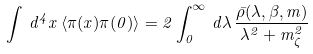<formula> <loc_0><loc_0><loc_500><loc_500>\int \, d ^ { 4 } x \, \langle \pi ( x ) \pi ( 0 ) \rangle = 2 \int _ { 0 } ^ { \infty } \, d \lambda \, \frac { \bar { \rho } ( \lambda , \beta , m ) } { \lambda ^ { 2 } + m _ { \zeta } ^ { 2 } }</formula> 